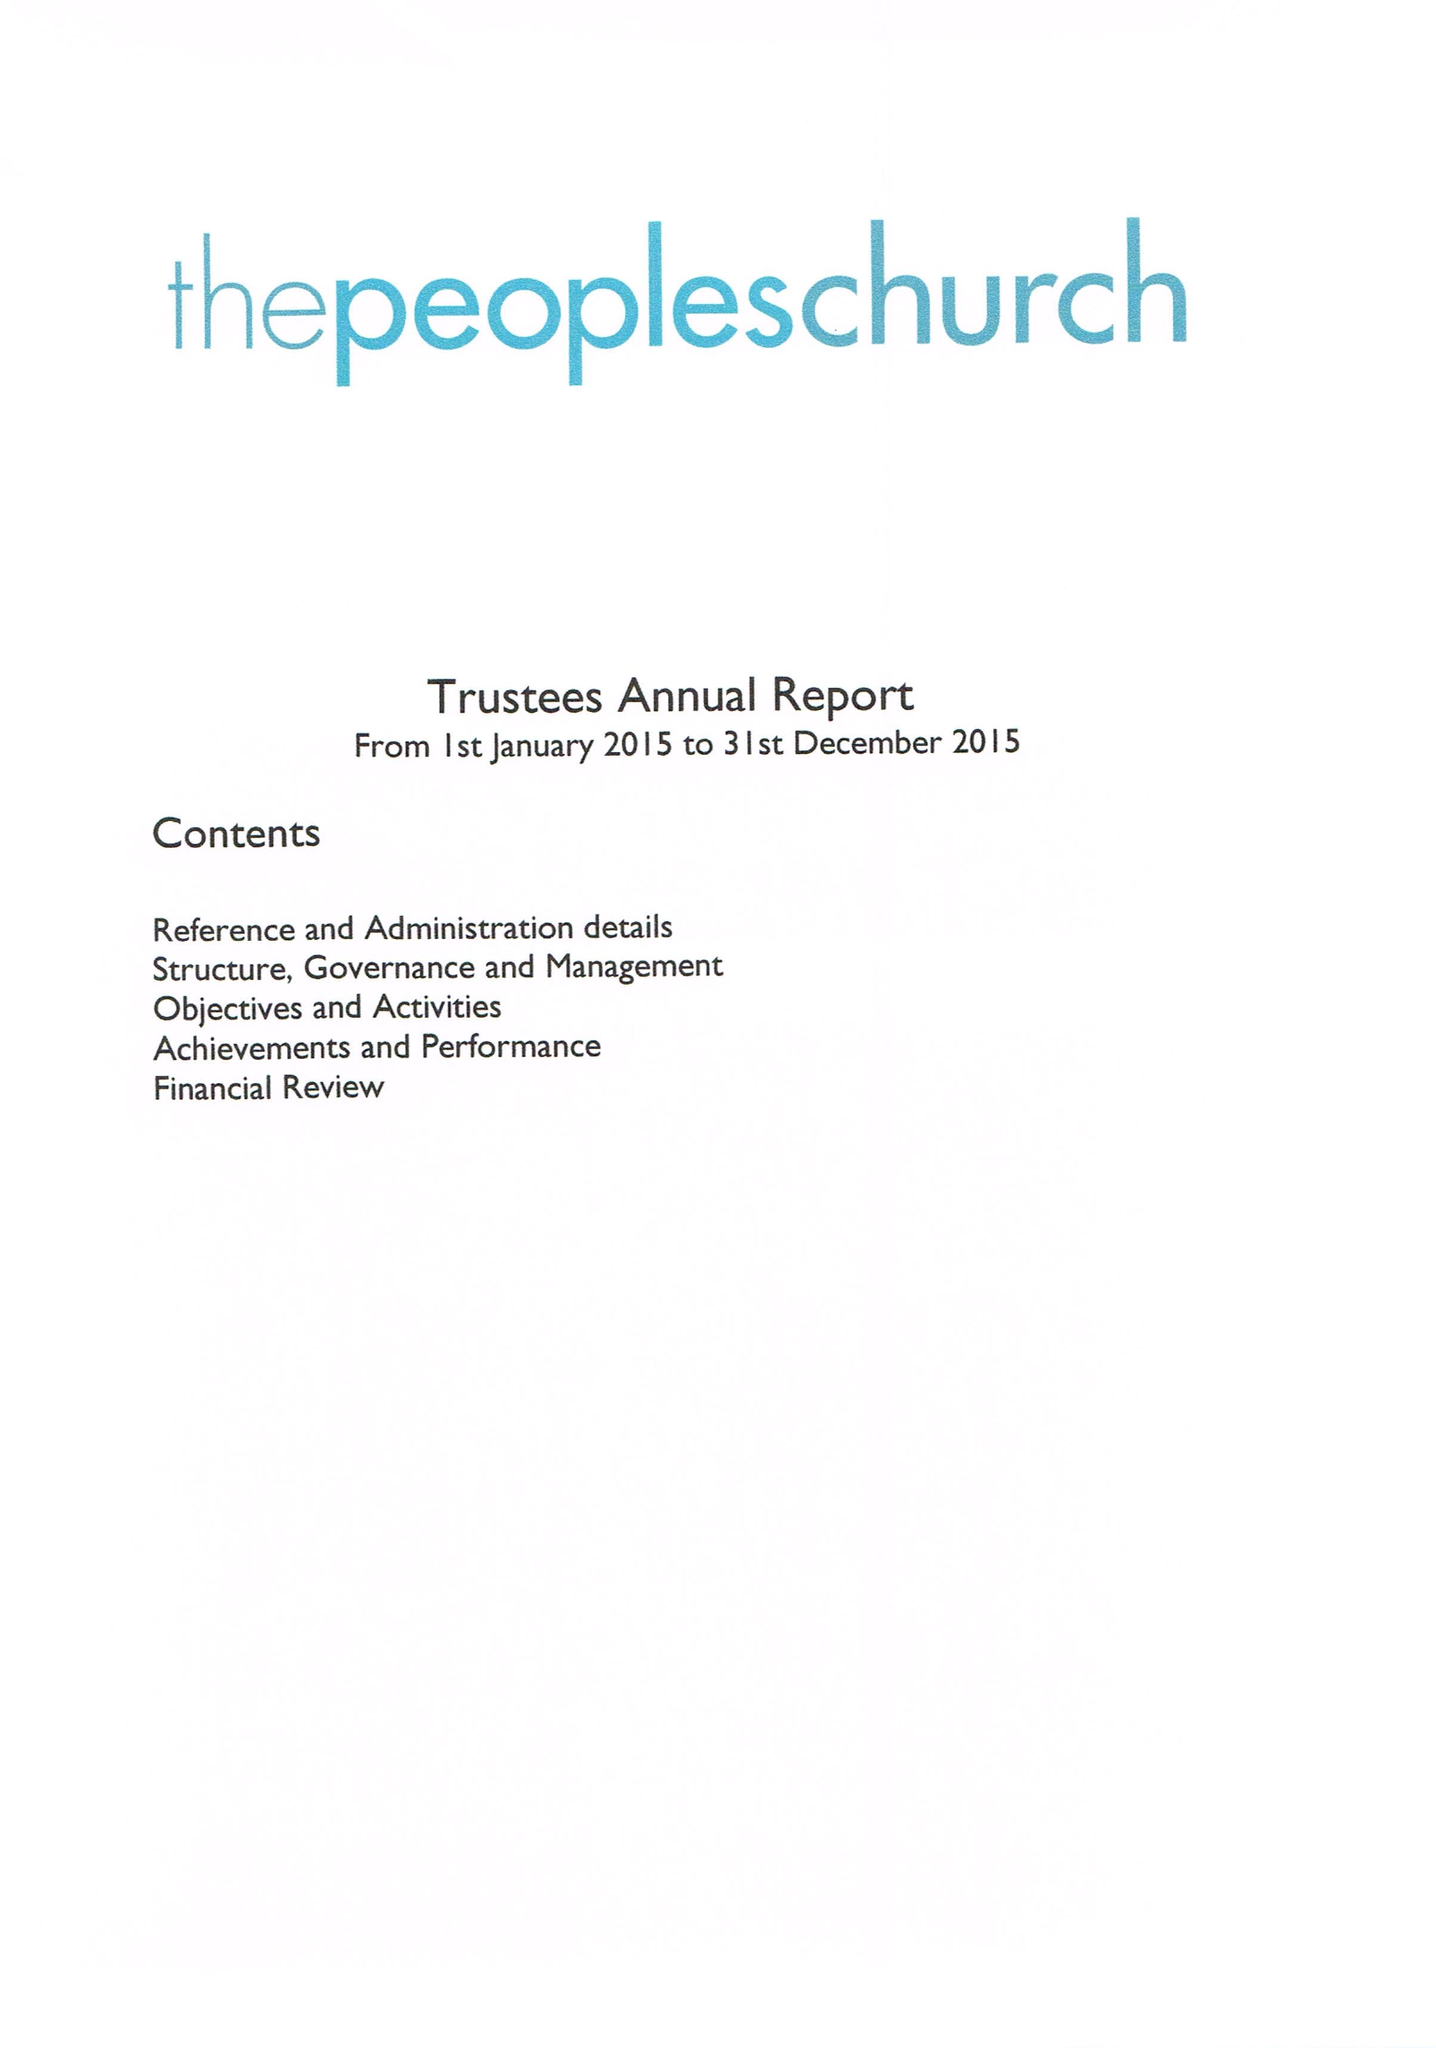What is the value for the report_date?
Answer the question using a single word or phrase. 2015-12-31 